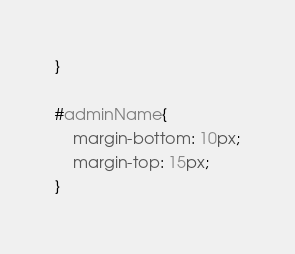Convert code to text. <code><loc_0><loc_0><loc_500><loc_500><_CSS_>}

#adminName{
    margin-bottom: 10px;
    margin-top: 15px;
}</code> 